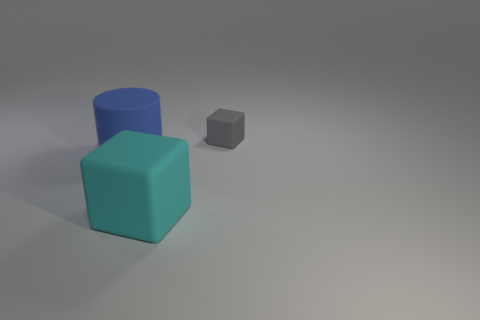There is a rubber thing right of the large block; does it have the same color as the large thing behind the big cyan matte object?
Ensure brevity in your answer.  No. Are there any tiny rubber cubes behind the tiny object?
Your response must be concise. No. What is the color of the thing that is behind the cyan thing and on the right side of the blue rubber cylinder?
Ensure brevity in your answer.  Gray. Is there a cylinder that has the same color as the tiny matte thing?
Provide a succinct answer. No. Does the large blue cylinder that is on the left side of the cyan matte block have the same material as the cube in front of the blue matte thing?
Your answer should be compact. Yes. What is the size of the thing that is in front of the large cylinder?
Offer a terse response. Large. What is the size of the cylinder?
Keep it short and to the point. Large. There is a matte thing on the left side of the cube that is in front of the matte block that is behind the cylinder; what is its size?
Give a very brief answer. Large. Is there a tiny cube that has the same material as the tiny thing?
Ensure brevity in your answer.  No. There is a blue matte thing; what shape is it?
Offer a terse response. Cylinder. 